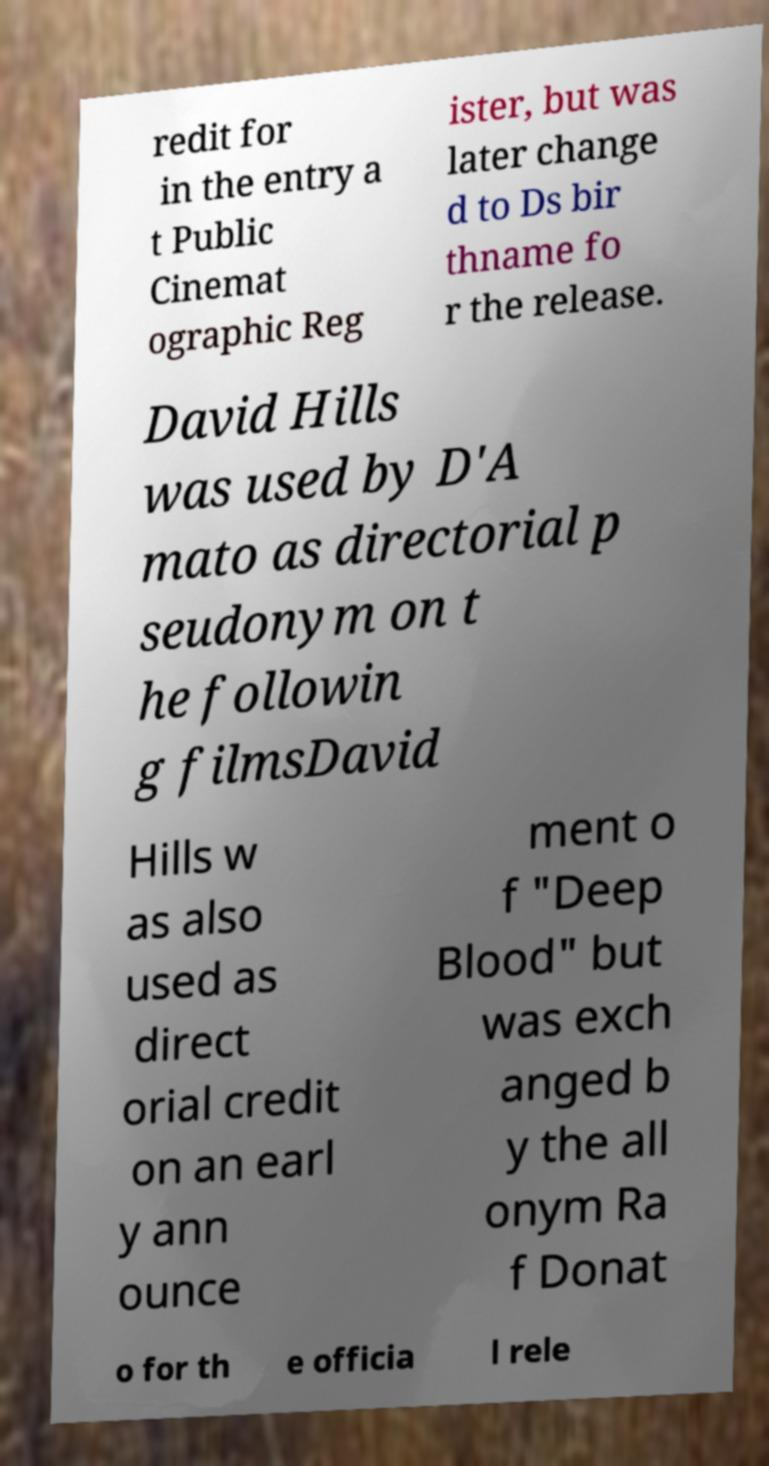There's text embedded in this image that I need extracted. Can you transcribe it verbatim? redit for in the entry a t Public Cinemat ographic Reg ister, but was later change d to Ds bir thname fo r the release. David Hills was used by D'A mato as directorial p seudonym on t he followin g filmsDavid Hills w as also used as direct orial credit on an earl y ann ounce ment o f "Deep Blood" but was exch anged b y the all onym Ra f Donat o for th e officia l rele 